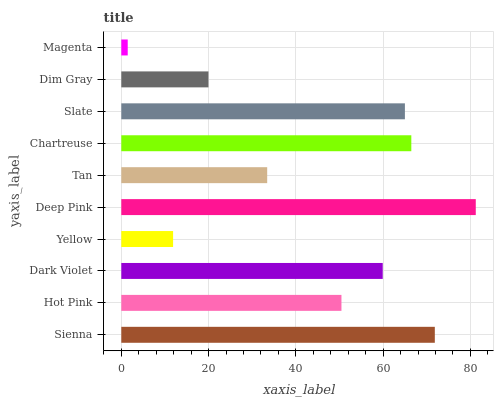Is Magenta the minimum?
Answer yes or no. Yes. Is Deep Pink the maximum?
Answer yes or no. Yes. Is Hot Pink the minimum?
Answer yes or no. No. Is Hot Pink the maximum?
Answer yes or no. No. Is Sienna greater than Hot Pink?
Answer yes or no. Yes. Is Hot Pink less than Sienna?
Answer yes or no. Yes. Is Hot Pink greater than Sienna?
Answer yes or no. No. Is Sienna less than Hot Pink?
Answer yes or no. No. Is Dark Violet the high median?
Answer yes or no. Yes. Is Hot Pink the low median?
Answer yes or no. Yes. Is Chartreuse the high median?
Answer yes or no. No. Is Dim Gray the low median?
Answer yes or no. No. 